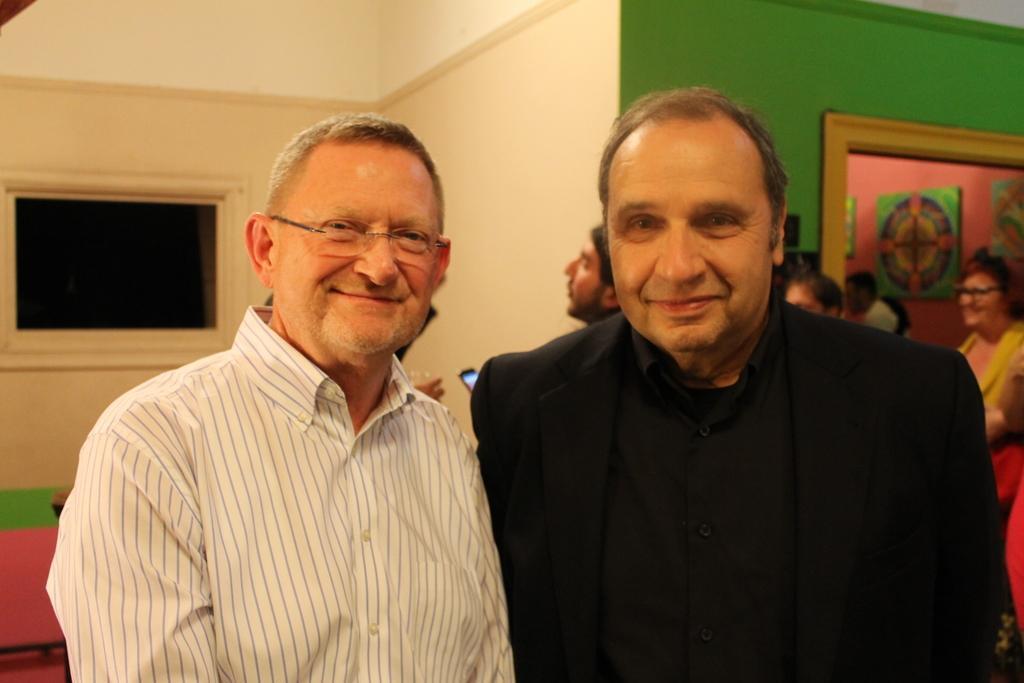Could you give a brief overview of what you see in this image? In this image in the front there are persons smiling. In the background there are persons, there is a mirror and there is a wall. 